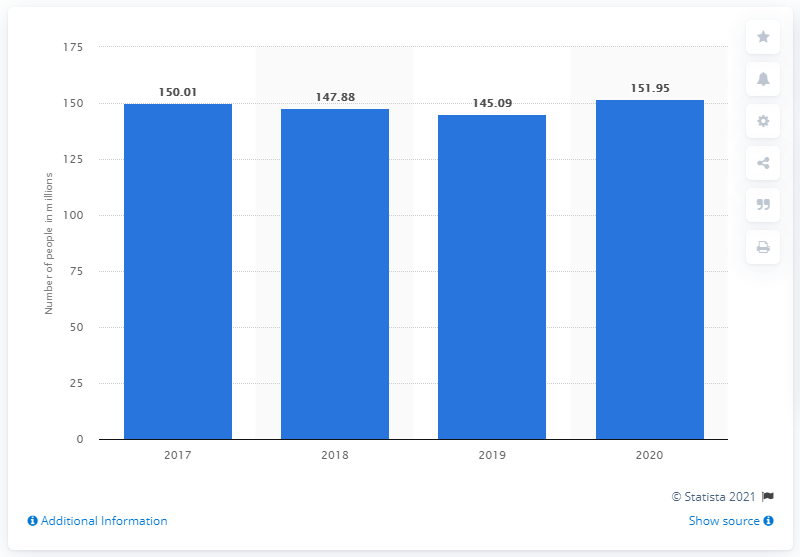Indicate a few pertinent items in this graphic. According to a survey conducted in 2020, it was estimated that 151.95 Americans intended to carve a pumpkin. 